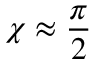<formula> <loc_0><loc_0><loc_500><loc_500>\chi \approx \frac { \pi } { 2 }</formula> 